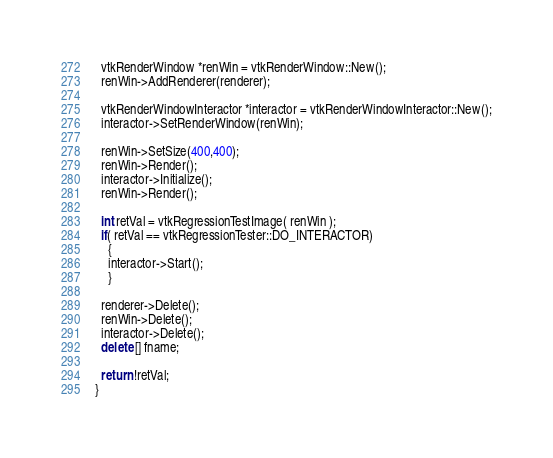<code> <loc_0><loc_0><loc_500><loc_500><_C++_>
  vtkRenderWindow *renWin = vtkRenderWindow::New();
  renWin->AddRenderer(renderer);

  vtkRenderWindowInteractor *interactor = vtkRenderWindowInteractor::New();
  interactor->SetRenderWindow(renWin);

  renWin->SetSize(400,400);
  renWin->Render();
  interactor->Initialize();
  renWin->Render();

  int retVal = vtkRegressionTestImage( renWin );
  if( retVal == vtkRegressionTester::DO_INTERACTOR)
    {
    interactor->Start();
    }

  renderer->Delete();
  renWin->Delete();
  interactor->Delete();
  delete [] fname;

  return !retVal;
}
</code> 